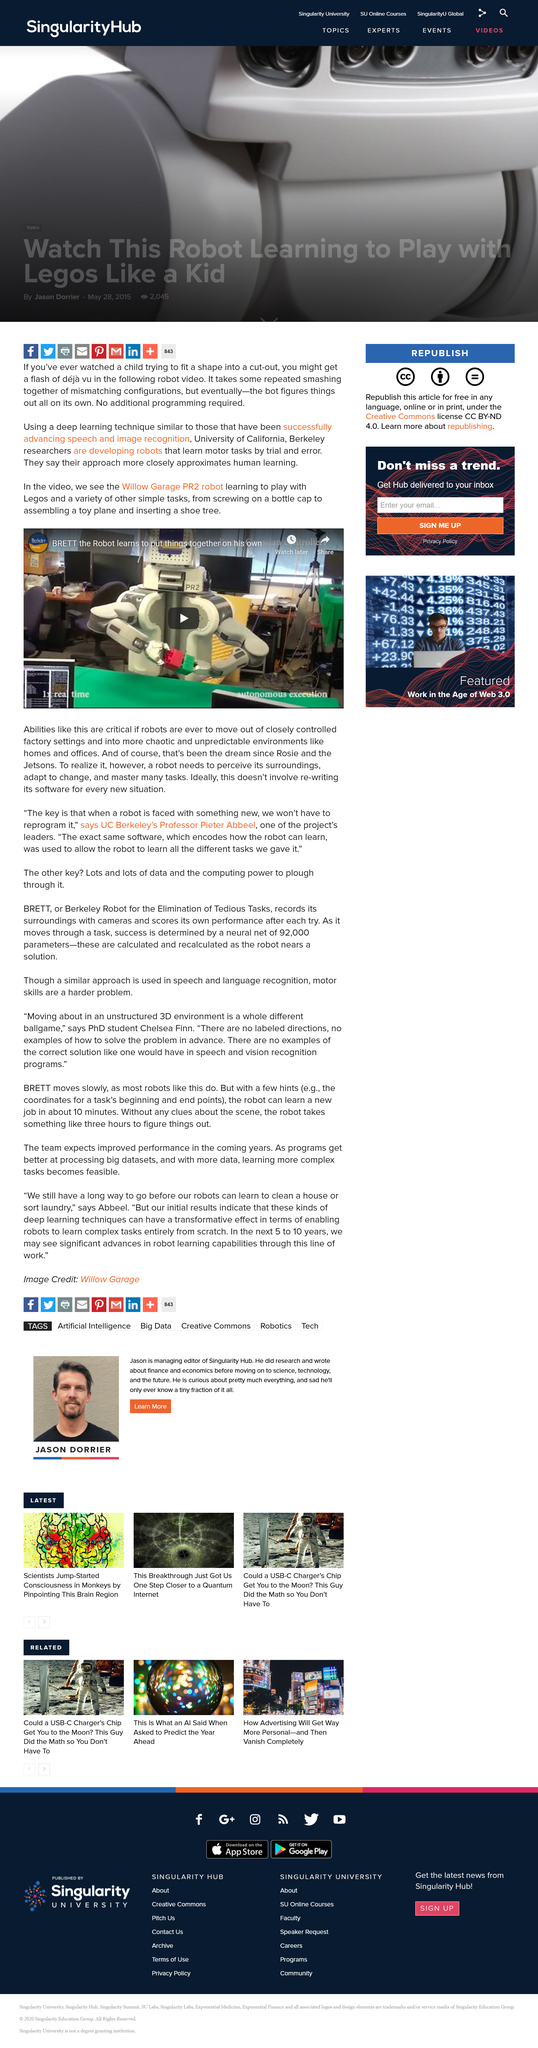List a handful of essential elements in this visual. The robot is shown in the video performing simple tasks such as screwing on a bottle cap, assembling a toy plane, and inserting a shoe tree. The University of California, Berkeley is developing robots that can learn motor skills. These robots, which are being developed by university researchers, are capable of acquiring new skills through observation and practice, similar to how humans learn. The researchers hope that these robots will be able to perform complex tasks autonomously, without the need for human intervention. The robot named BRETT, which is featured in the video, is officially known as the Willow Garage PR2 robot. 